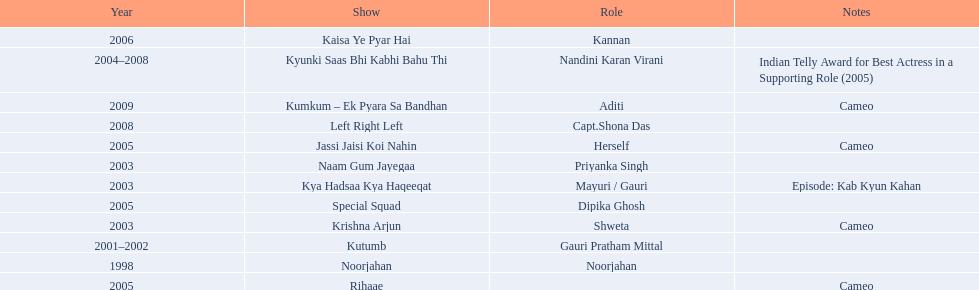What shows has gauri pradhan tejwani been in? Noorjahan, Kutumb, Krishna Arjun, Naam Gum Jayegaa, Kya Hadsaa Kya Haqeeqat, Kyunki Saas Bhi Kabhi Bahu Thi, Rihaae, Jassi Jaisi Koi Nahin, Special Squad, Kaisa Ye Pyar Hai, Left Right Left, Kumkum – Ek Pyara Sa Bandhan. Of these shows, which one lasted for more than a year? Kutumb, Kyunki Saas Bhi Kabhi Bahu Thi. Which of these lasted the longest? Kyunki Saas Bhi Kabhi Bahu Thi. 